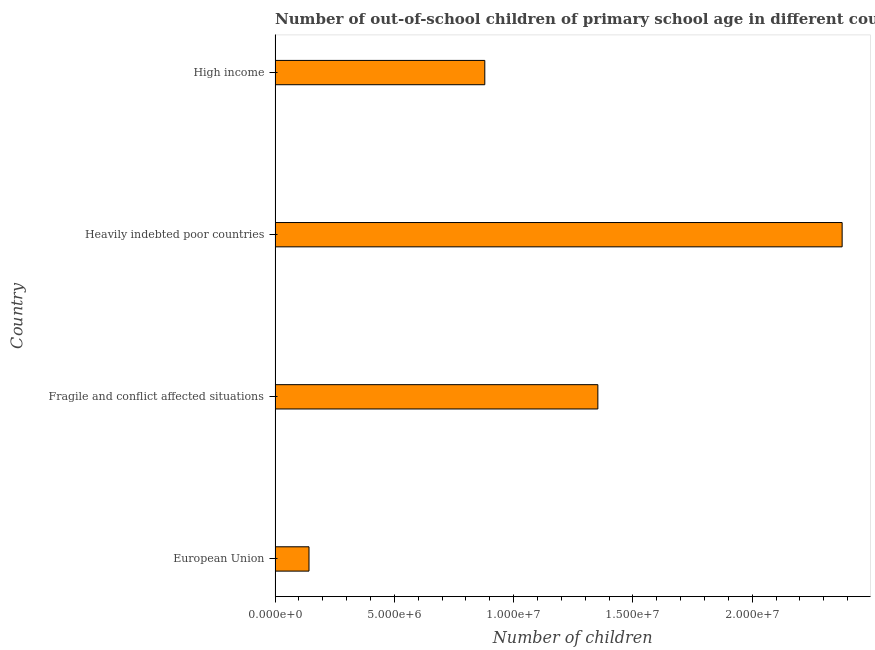Does the graph contain any zero values?
Keep it short and to the point. No. What is the title of the graph?
Provide a succinct answer. Number of out-of-school children of primary school age in different countries. What is the label or title of the X-axis?
Your answer should be compact. Number of children. What is the number of out-of-school children in Fragile and conflict affected situations?
Offer a terse response. 1.35e+07. Across all countries, what is the maximum number of out-of-school children?
Provide a succinct answer. 2.38e+07. Across all countries, what is the minimum number of out-of-school children?
Ensure brevity in your answer.  1.42e+06. In which country was the number of out-of-school children maximum?
Provide a short and direct response. Heavily indebted poor countries. In which country was the number of out-of-school children minimum?
Make the answer very short. European Union. What is the sum of the number of out-of-school children?
Your answer should be compact. 4.75e+07. What is the difference between the number of out-of-school children in European Union and Fragile and conflict affected situations?
Ensure brevity in your answer.  -1.21e+07. What is the average number of out-of-school children per country?
Offer a terse response. 1.19e+07. What is the median number of out-of-school children?
Give a very brief answer. 1.12e+07. What is the ratio of the number of out-of-school children in Fragile and conflict affected situations to that in Heavily indebted poor countries?
Make the answer very short. 0.57. Is the number of out-of-school children in Fragile and conflict affected situations less than that in Heavily indebted poor countries?
Give a very brief answer. Yes. Is the difference between the number of out-of-school children in European Union and High income greater than the difference between any two countries?
Offer a terse response. No. What is the difference between the highest and the second highest number of out-of-school children?
Provide a succinct answer. 1.02e+07. What is the difference between the highest and the lowest number of out-of-school children?
Give a very brief answer. 2.23e+07. How many countries are there in the graph?
Offer a very short reply. 4. What is the difference between two consecutive major ticks on the X-axis?
Keep it short and to the point. 5.00e+06. Are the values on the major ticks of X-axis written in scientific E-notation?
Make the answer very short. Yes. What is the Number of children in European Union?
Your answer should be compact. 1.42e+06. What is the Number of children in Fragile and conflict affected situations?
Make the answer very short. 1.35e+07. What is the Number of children in Heavily indebted poor countries?
Ensure brevity in your answer.  2.38e+07. What is the Number of children in High income?
Ensure brevity in your answer.  8.79e+06. What is the difference between the Number of children in European Union and Fragile and conflict affected situations?
Ensure brevity in your answer.  -1.21e+07. What is the difference between the Number of children in European Union and Heavily indebted poor countries?
Offer a terse response. -2.23e+07. What is the difference between the Number of children in European Union and High income?
Ensure brevity in your answer.  -7.37e+06. What is the difference between the Number of children in Fragile and conflict affected situations and Heavily indebted poor countries?
Keep it short and to the point. -1.02e+07. What is the difference between the Number of children in Fragile and conflict affected situations and High income?
Your answer should be compact. 4.74e+06. What is the difference between the Number of children in Heavily indebted poor countries and High income?
Offer a terse response. 1.50e+07. What is the ratio of the Number of children in European Union to that in Fragile and conflict affected situations?
Offer a terse response. 0.1. What is the ratio of the Number of children in European Union to that in Heavily indebted poor countries?
Offer a very short reply. 0.06. What is the ratio of the Number of children in European Union to that in High income?
Ensure brevity in your answer.  0.16. What is the ratio of the Number of children in Fragile and conflict affected situations to that in Heavily indebted poor countries?
Provide a succinct answer. 0.57. What is the ratio of the Number of children in Fragile and conflict affected situations to that in High income?
Your answer should be very brief. 1.54. What is the ratio of the Number of children in Heavily indebted poor countries to that in High income?
Ensure brevity in your answer.  2.7. 